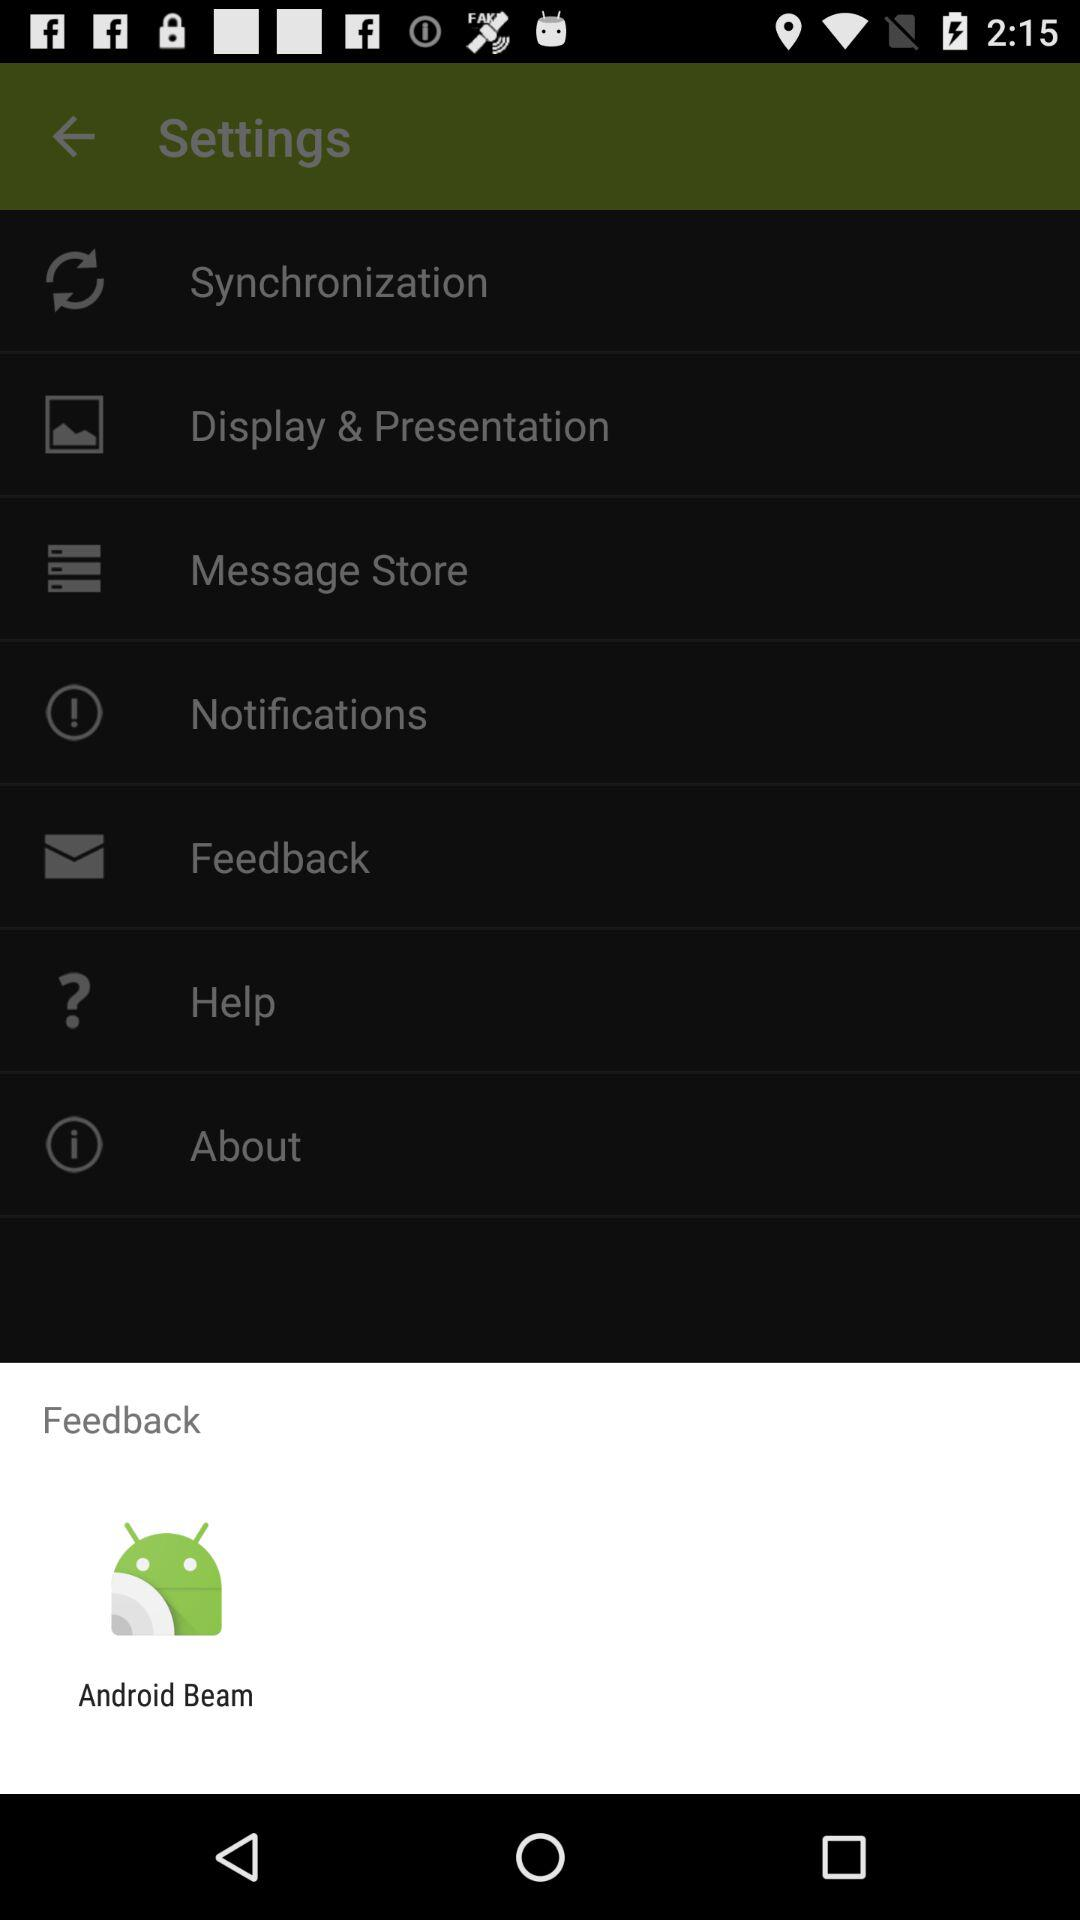By using what application can we send feedback? You can send feedback by using "Android Beam". 